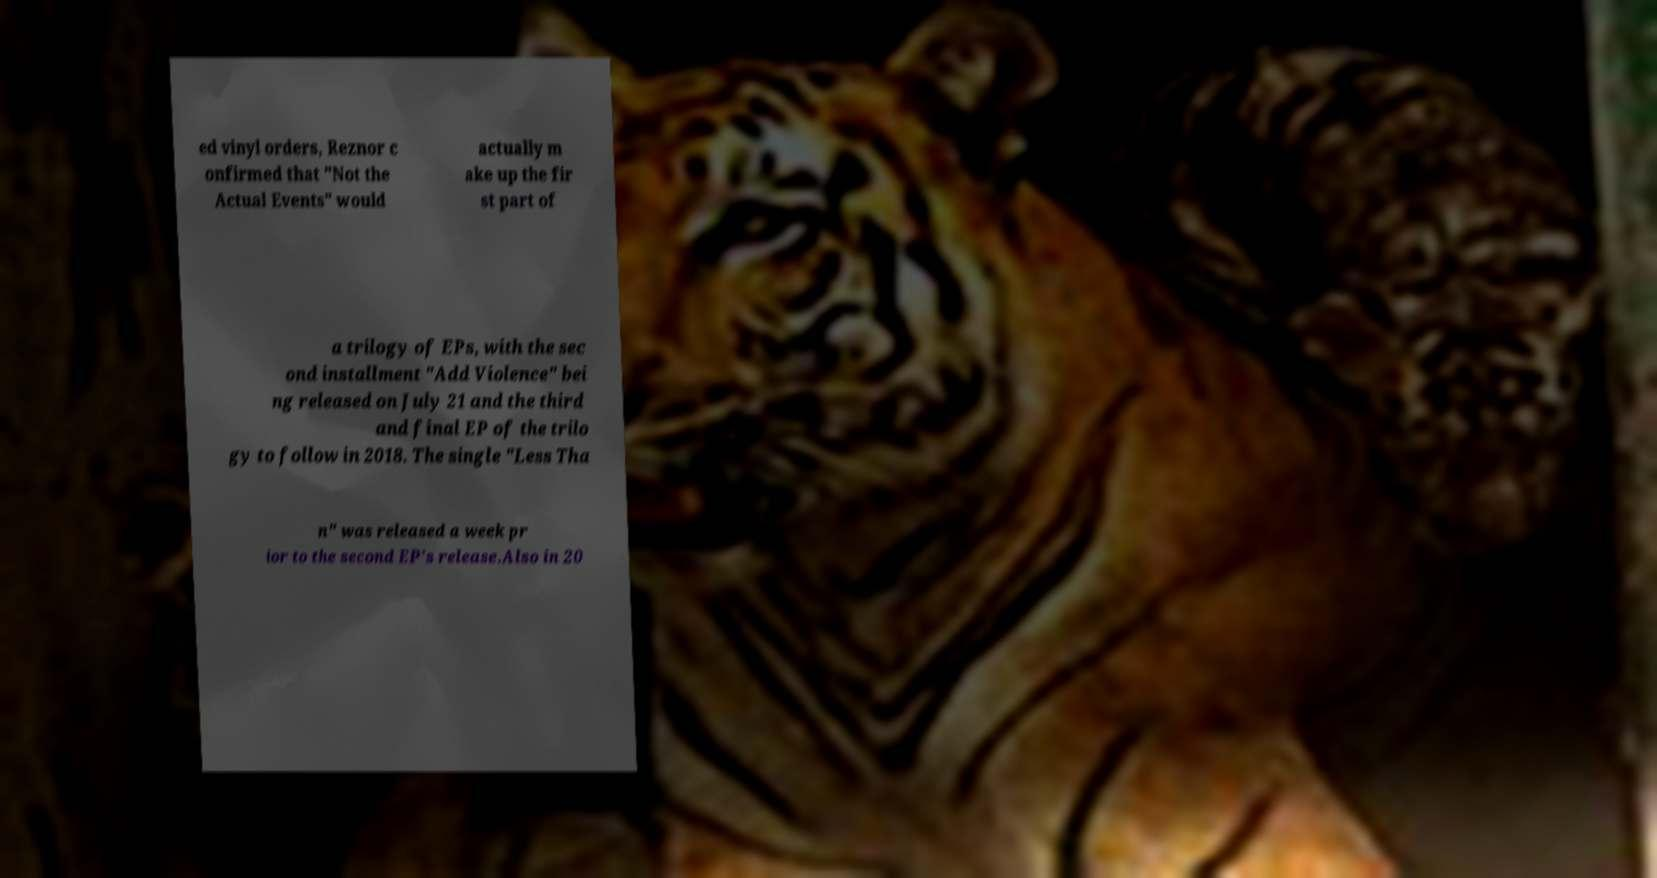Could you extract and type out the text from this image? ed vinyl orders, Reznor c onfirmed that "Not the Actual Events" would actually m ake up the fir st part of a trilogy of EPs, with the sec ond installment "Add Violence" bei ng released on July 21 and the third and final EP of the trilo gy to follow in 2018. The single "Less Tha n" was released a week pr ior to the second EP's release.Also in 20 